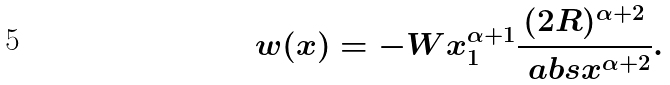Convert formula to latex. <formula><loc_0><loc_0><loc_500><loc_500>w ( x ) = - W x _ { 1 } ^ { \alpha + 1 } \frac { ( 2 R ) ^ { \alpha + 2 } } { \ a b s { x } ^ { \alpha + 2 } } .</formula> 